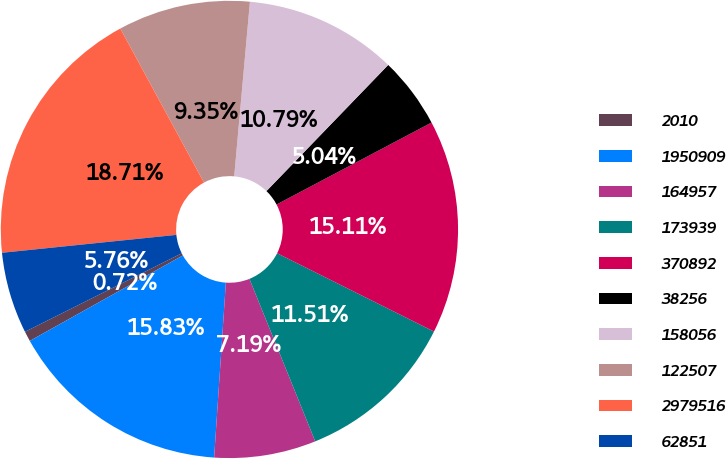Convert chart. <chart><loc_0><loc_0><loc_500><loc_500><pie_chart><fcel>2010<fcel>1950909<fcel>164957<fcel>173939<fcel>370892<fcel>38256<fcel>158056<fcel>122507<fcel>2979516<fcel>62851<nl><fcel>0.72%<fcel>15.83%<fcel>7.19%<fcel>11.51%<fcel>15.11%<fcel>5.04%<fcel>10.79%<fcel>9.35%<fcel>18.71%<fcel>5.76%<nl></chart> 